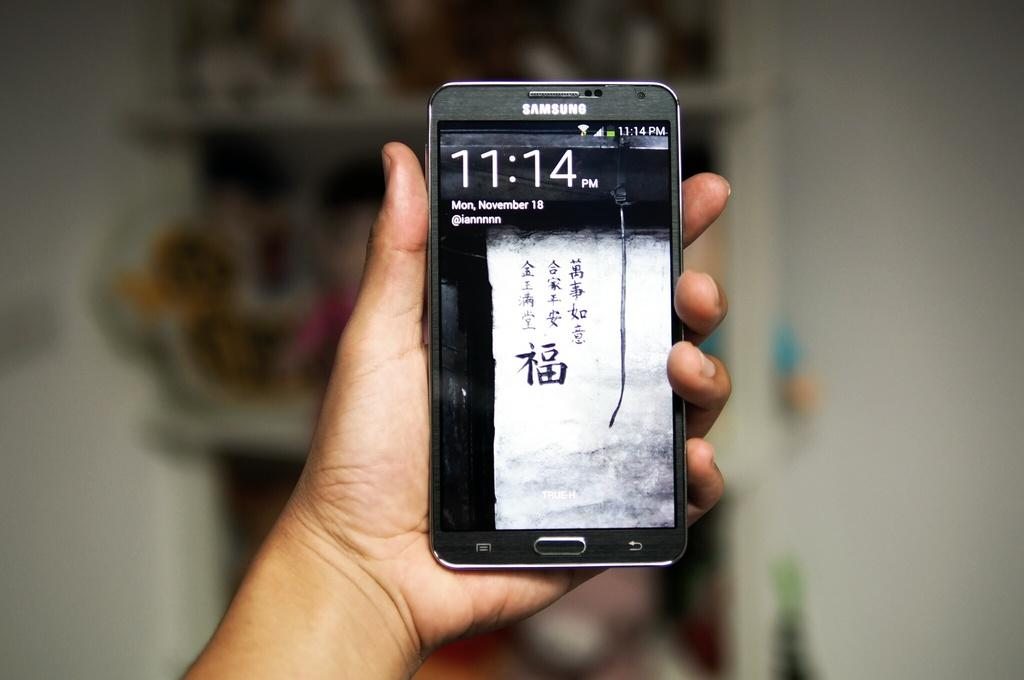<image>
Share a concise interpretation of the image provided. The black slim cell phone is a Samsung. 